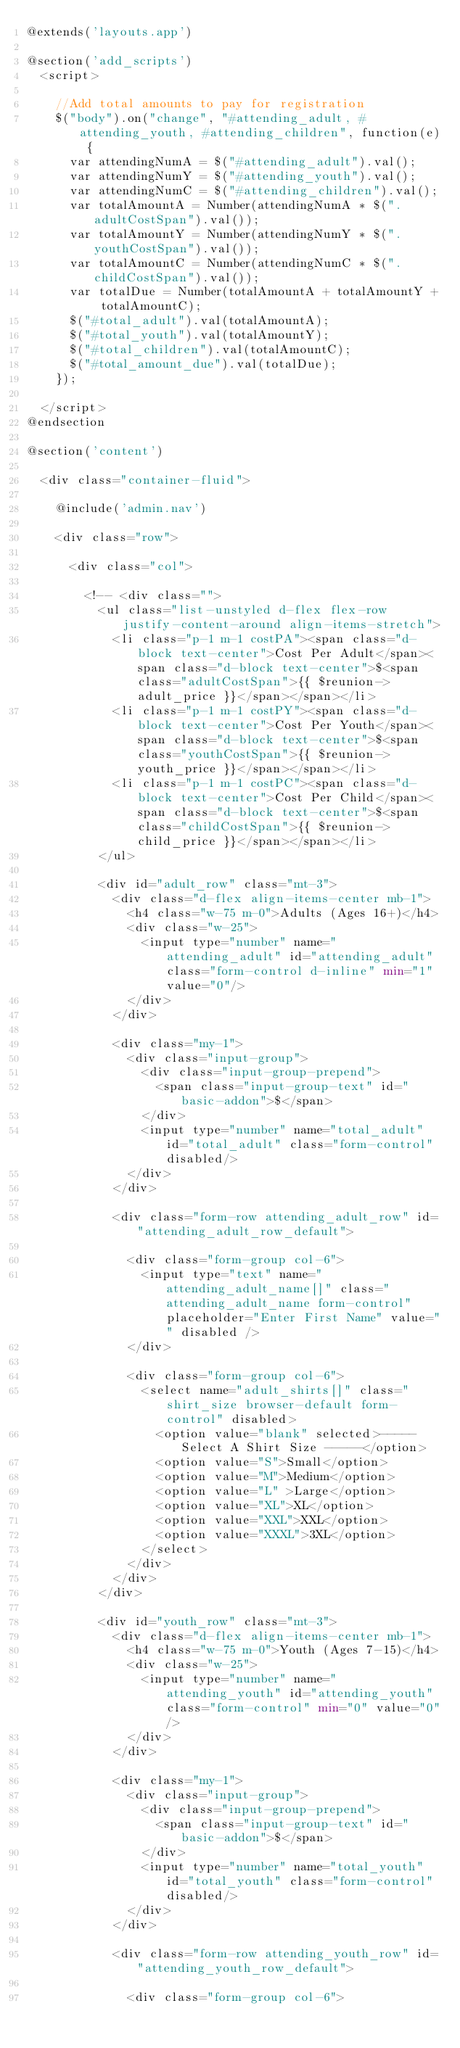Convert code to text. <code><loc_0><loc_0><loc_500><loc_500><_PHP_>@extends('layouts.app')

@section('add_scripts')
	<script>

		//Add total amounts to pay for registration
		$("body").on("change", "#attending_adult, #attending_youth, #attending_children", function(e) {
			var attendingNumA = $("#attending_adult").val();
			var attendingNumY = $("#attending_youth").val();
			var attendingNumC = $("#attending_children").val();
			var totalAmountA = Number(attendingNumA * $(".adultCostSpan").val());
			var totalAmountY = Number(attendingNumY * $(".youthCostSpan").val());
			var totalAmountC = Number(attendingNumC * $(".childCostSpan").val());
			var totalDue = Number(totalAmountA + totalAmountY + totalAmountC);
			$("#total_adult").val(totalAmountA);
			$("#total_youth").val(totalAmountY);
			$("#total_children").val(totalAmountC);
			$("#total_amount_due").val(totalDue);
		});
		
	</script>
@endsection

@section('content')
	
	<div class="container-fluid">
	
		@include('admin.nav')
		
		<div class="row">
		
			<div class="col">
			
				<!-- <div class="">
					<ul class="list-unstyled d-flex flex-row justify-content-around align-items-stretch">
						<li class="p-1 m-1 costPA"><span class="d-block text-center">Cost Per Adult</span><span class="d-block text-center">$<span class="adultCostSpan">{{ $reunion->adult_price }}</span></span></li>
						<li class="p-1 m-1 costPY"><span class="d-block text-center">Cost Per Youth</span><span class="d-block text-center">$<span class="youthCostSpan">{{ $reunion->youth_price }}</span></span></li>
						<li class="p-1 m-1 costPC"><span class="d-block text-center">Cost Per Child</span><span class="d-block text-center">$<span class="childCostSpan">{{ $reunion->child_price }}</span></span></li>
					</ul>
					
					<div id="adult_row" class="mt-3">
						<div class="d-flex align-items-center mb-1">
							<h4 class="w-75 m-0">Adults (Ages 16+)</h4>
							<div class="w-25">
								<input type="number" name="attending_adult" id="attending_adult" class="form-control d-inline" min="1" value="0"/>
							</div>
						</div>
						
						<div class="my-1">
							<div class="input-group">
								<div class="input-group-prepend">
									<span class="input-group-text" id="basic-addon">$</span>
								</div>
								<input type="number" name="total_adult" id="total_adult" class="form-control" disabled/>
							</div>
						</div>

						<div class="form-row attending_adult_row" id="attending_adult_row_default">
						
							<div class="form-group col-6">
								<input type="text" name="attending_adult_name[]" class="attending_adult_name form-control" placeholder="Enter First Name" value="" disabled />
							</div>
							
							<div class="form-group col-6">
								<select name="adult_shirts[]" class="shirt_size browser-default form-control" disabled>
									<option value="blank" selected>----- Select A Shirt Size -----</option>
									<option value="S">Small</option>
									<option value="M">Medium</option>
									<option value="L" >Large</option>
									<option value="XL">XL</option>
									<option value="XXL">XXL</option>
									<option value="XXXL">3XL</option>
								</select>
							</div>
						</div>
					</div>
					
					<div id="youth_row" class="mt-3">
						<div class="d-flex align-items-center mb-1">
							<h4 class="w-75 m-0">Youth (Ages 7-15)</h4>
							<div class="w-25">
								<input type="number" name="attending_youth" id="attending_youth" class="form-control" min="0" value="0"/>
							</div>
						</div>
						
						<div class="my-1">
							<div class="input-group">
								<div class="input-group-prepend">
									<span class="input-group-text" id="basic-addon">$</span>
								</div>
								<input type="number" name="total_youth" id="total_youth" class="form-control" disabled/>
							</div>
						</div>

						<div class="form-row attending_youth_row" id="attending_youth_row_default">
						
							<div class="form-group col-6"></code> 